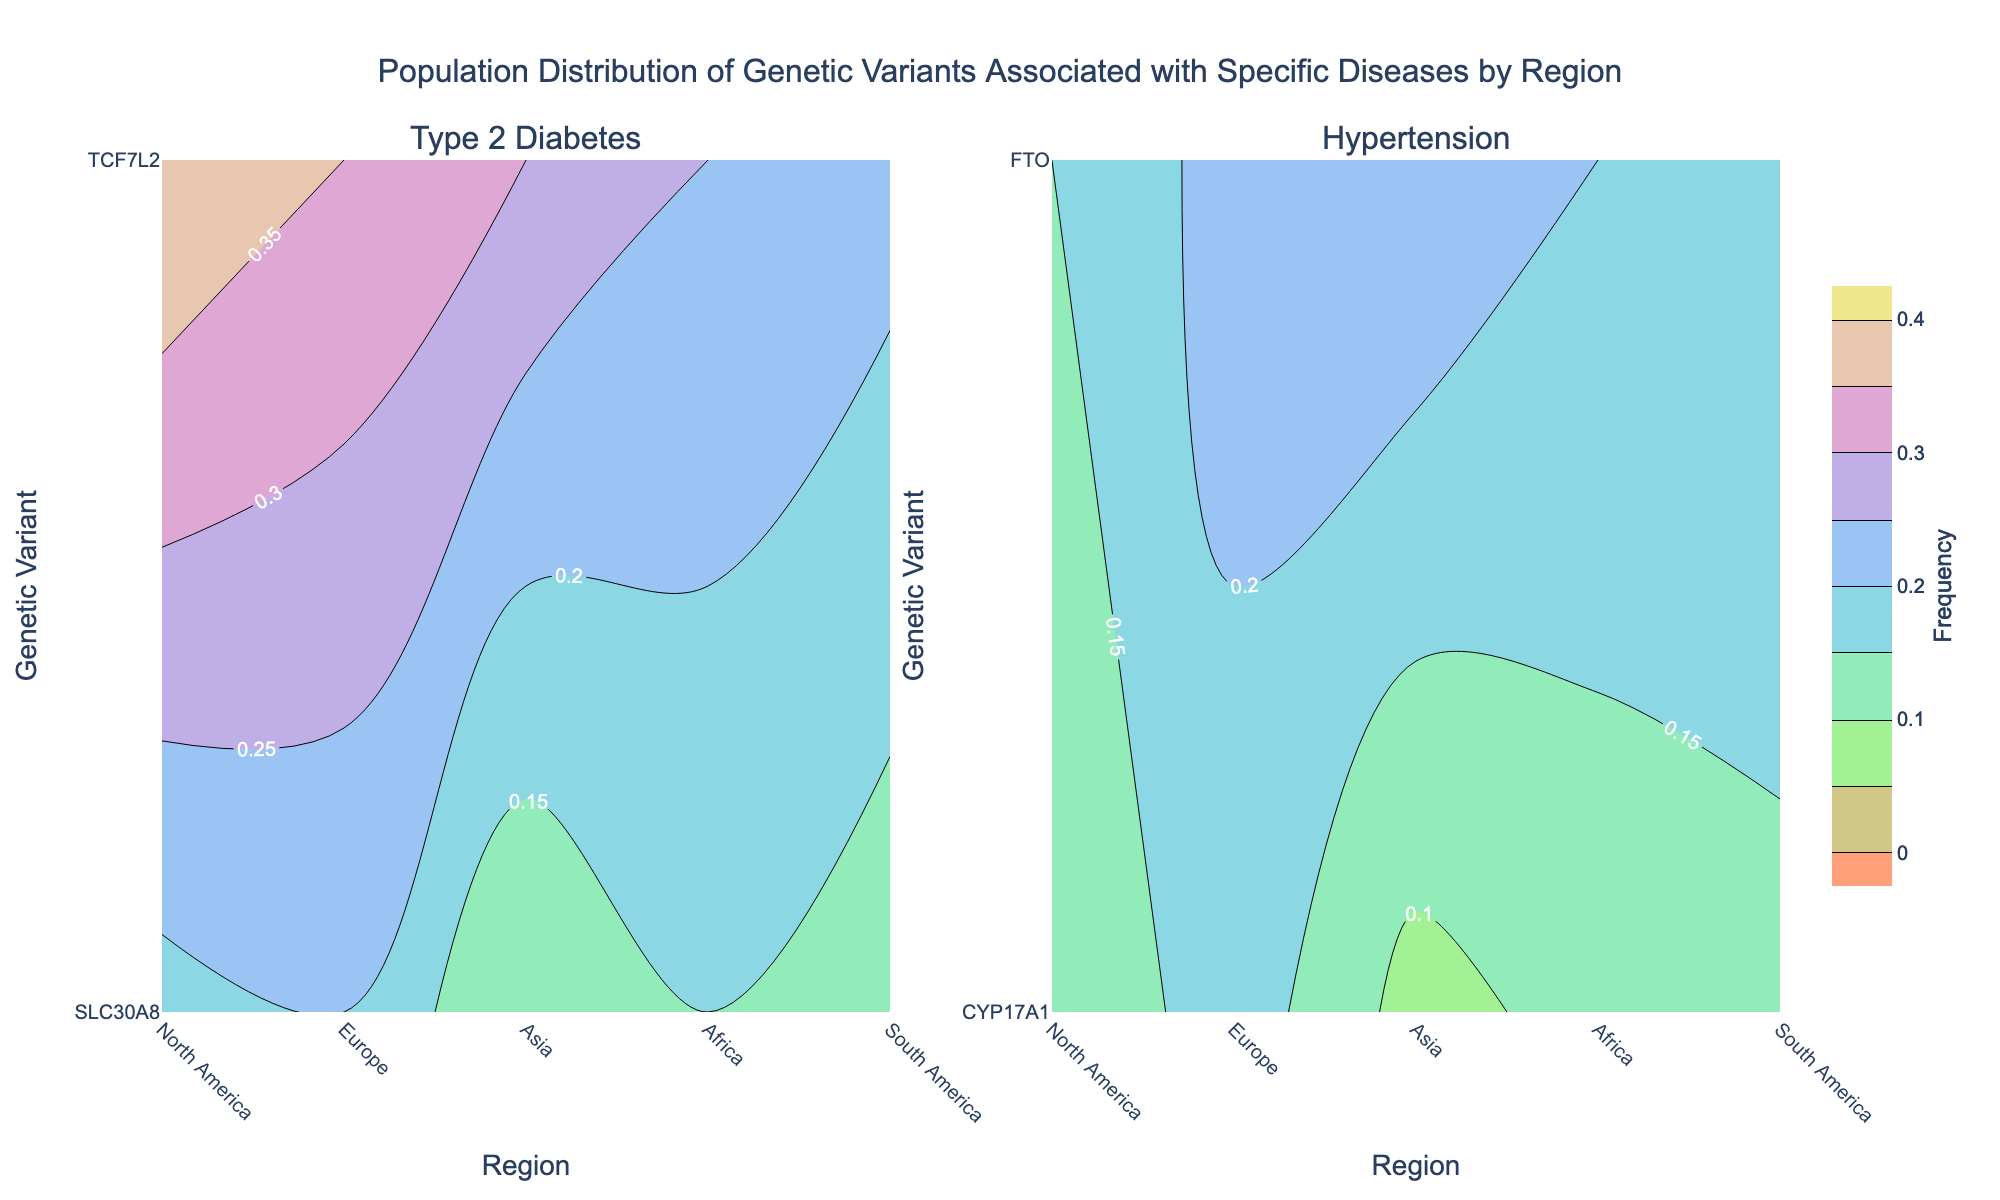What is the title of the figure? The title is located at the top center of the figure and reads: "Population Distribution of Genetic Variants Associated with Specific Diseases by Region"
Answer: Population Distribution of Genetic Variants Associated with Specific Diseases by Region How many subplots are there in the figure? The figure consists of two subplots, one for 'Type 2 Diabetes' and one for 'Hypertension'. This can be seen from the subplot titles above each chart.
Answer: 2 Which genetic variant has the highest frequency for Type 2 Diabetes in Africa? By looking at the contour plot for Type 2 Diabetes in Africa, we can see that the highest frequency is 0.40 for the genetic variant TCF7L2, as indicated by the color gradient and labels.
Answer: TCF7L2 For Hypertension, which region has the highest frequency for the genetic variant FTO? In the subplot for Hypertension, the contour lines indicate that Europe has the highest frequency for the genetic variant FTO at 0.25, as shown by the color scale and labels.
Answer: Europe Compare the frequencies of the genetic variant SLC30A8 for Type 2 Diabetes across North America and Asia. Which region has a higher frequency? For Type 2 Diabetes, the subplot shows the frequency for SLC30A8 as 0.15 in North America and 0.20 in Asia. Thus, Asia has a higher frequency for this genetic variant.
Answer: Asia What is the average frequency of the genetic variant CYP17A1 across all regions for Hypertension? To calculate the average, add the frequencies for each region (0.12 + 0.08 + 0.18 + 0.10 + 0.14) and divide by the number of regions: (0.12 + 0.08 + 0.18 + 0.10 + 0.14)/5 = 0.124.
Answer: 0.124 Which disease shows a higher overall frequency of genetic variants in Africa? By comparing the contours, Type 2 Diabetes has higher frequencies overall (0.18 and 0.40 for SLC30A8 and TCF7L2 respectively) compared to Hypertension (0.10 and 0.15 for CYP17A1 and FTO respectively).
Answer: Type 2 Diabetes What is the range of frequencies for the genetic variant TCF7L2 for Type 2 Diabetes across all regions? The frequencies for TCF7L2 in Type 2 Diabetes are: North America (0.25), Europe (0.30), Asia (0.35), Africa (0.40), South America (0.22). The range is found by subtracting the smallest value from the highest value: 0.40 - 0.22 = 0.18.
Answer: 0.18 Which genetic variant has the smallest frequency in Europe for Hypertension? In the subplot for Hypertension, the genetic variant CYP17A1 has the smallest frequency at 0.08 in Europe, as indicated by the contour labels.
Answer: CYP17A1 